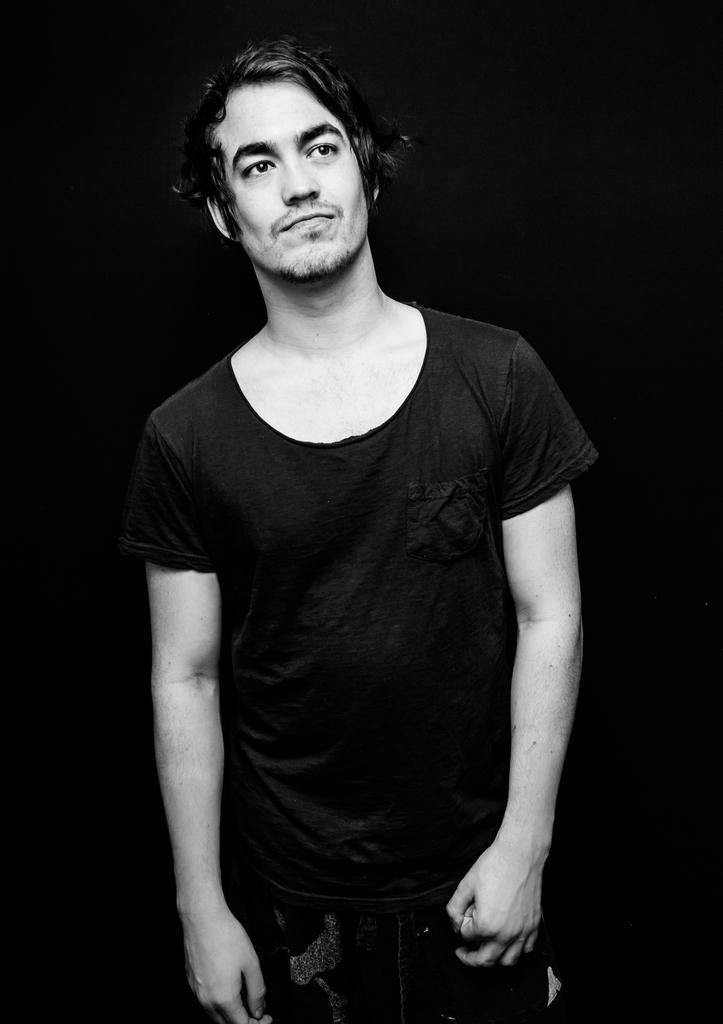What is present in the image? There is a man in the image. What is the man wearing? The man is wearing a black t-shirt. What type of cup is the man holding in the image? There is no cup present in the image. Is the man performing on a stage in the image? There is no stage present in the image. 